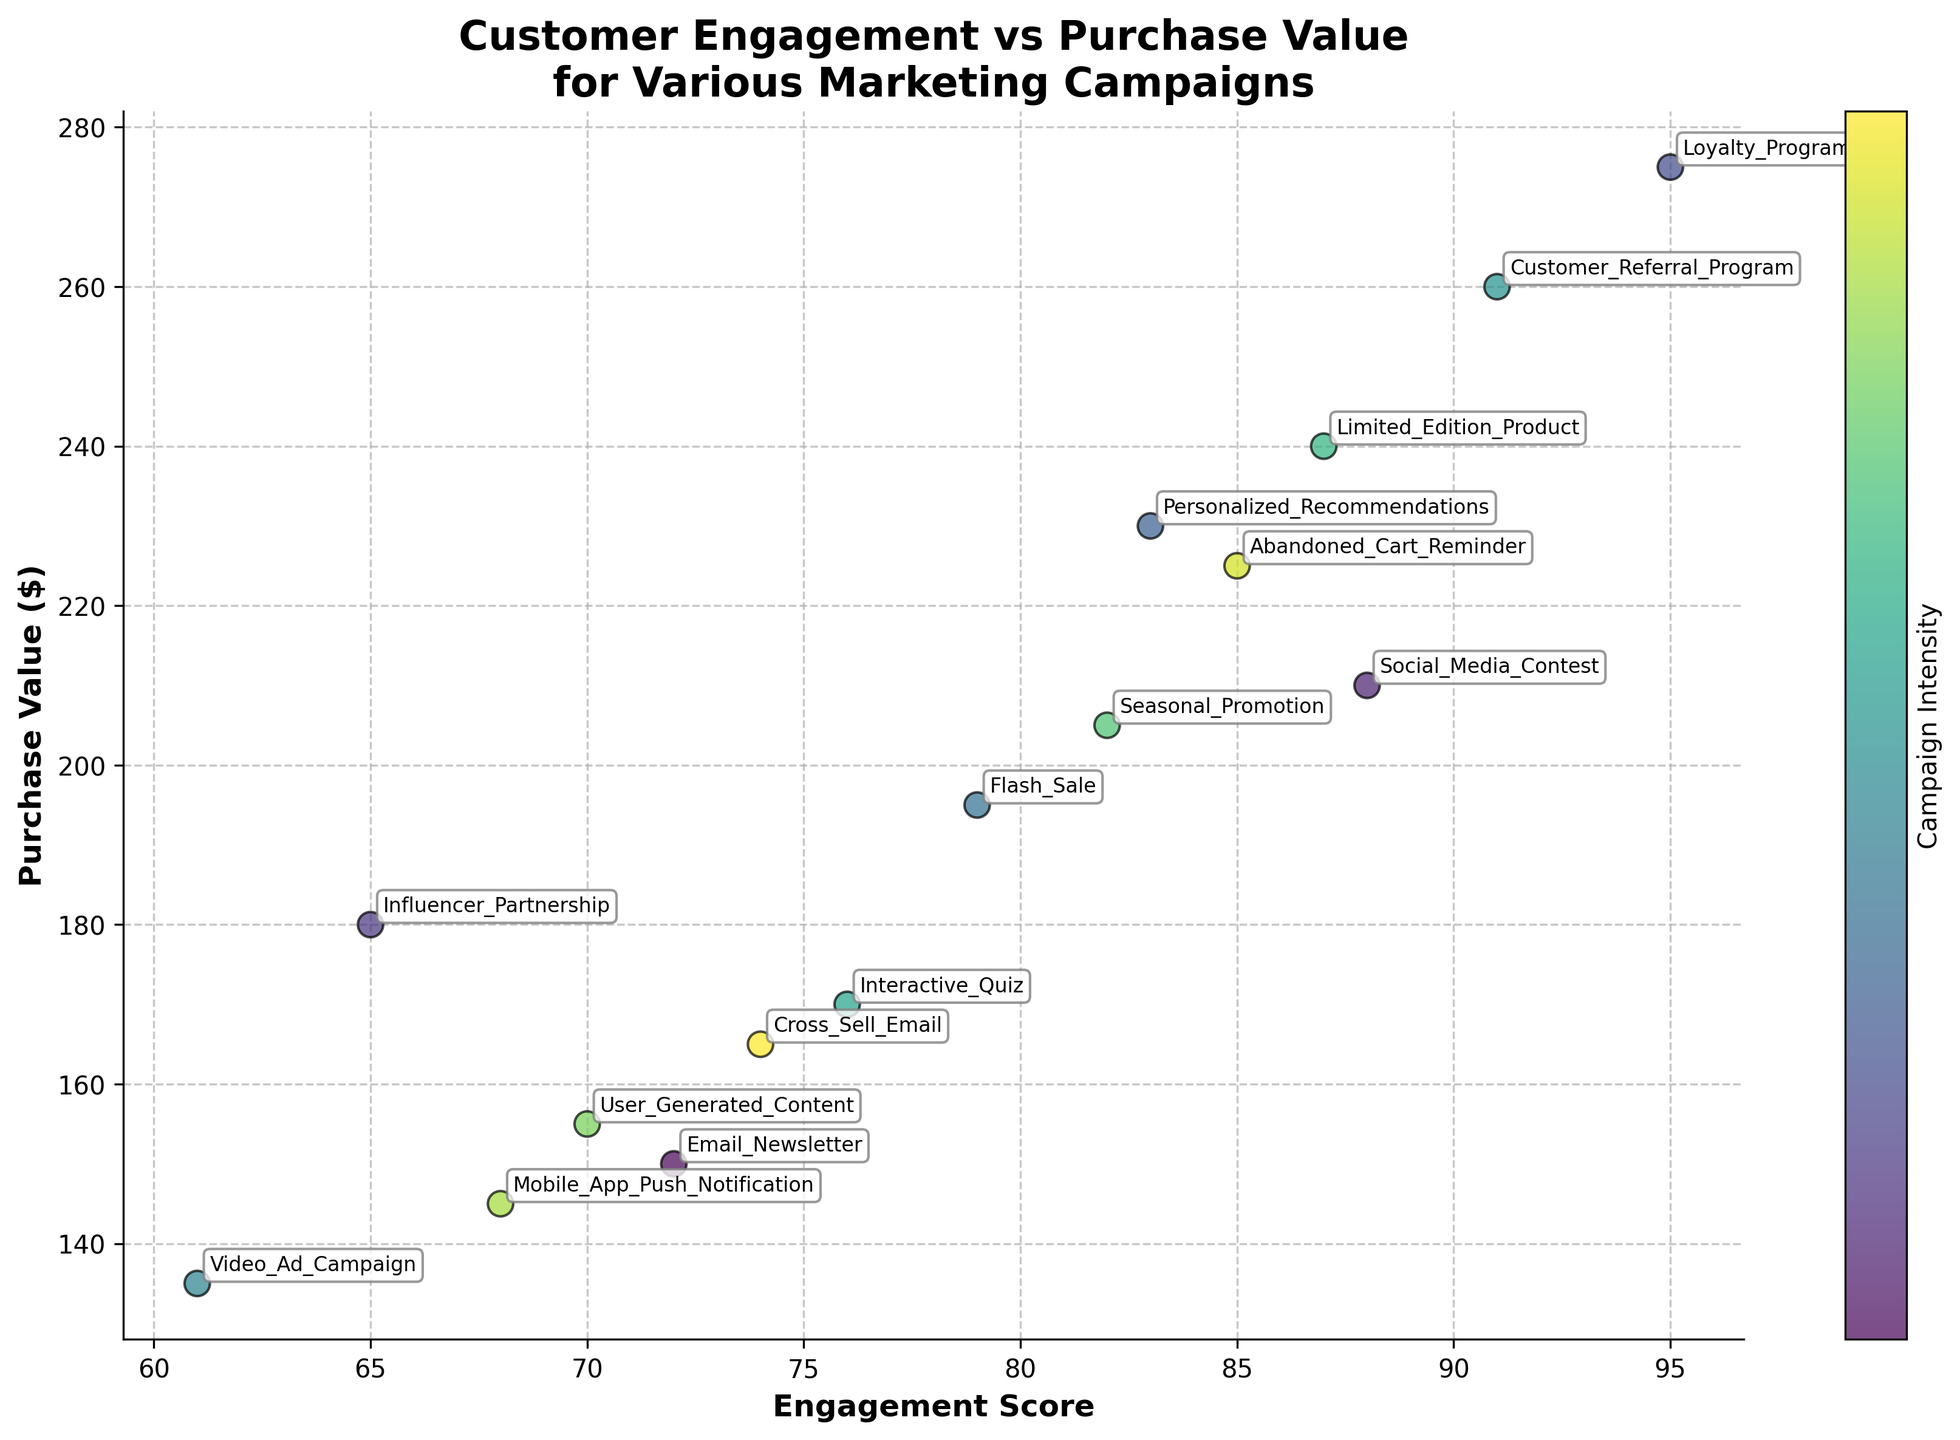What is the title of the plot? The title is displayed at the top of the plot and describes the overall data being shown. The title is detailed and should precisely describe the main focus of the plot.
Answer: Customer Engagement vs Purchase Value for Various Marketing Campaigns What are the x-axis and y-axis labels? The x-axis and y-axis labels are indicated along the axes in bold text. The x-axis label represents the horizontal component, and the y-axis label represents the vertical component.
Answer: Engagement Score; Purchase Value ($) How many campaigns are plotted in the figure? Each campaign is represented by a distinct data point in the scatter plot. The number of distinct annotations in the plot corresponds to the number of campaigns.
Answer: 15 Which campaign has the highest purchase value? Looking at the data points, the one with the highest y-value represents the campaign with the highest purchase value. The data point will likely have an annotation.
Answer: Loyalty Program Which campaigns have engagement scores above 80? Identify the data points to the right of the 80 mark on the x-axis. The annotations at or near these points represent the relevant campaigns.
Answer: Loyalty Program, Personalized Recommendations, Social Media Contest, Limited Edition Product, Customer Referral Program, Abandoned Cart Reminder, Seasonal Promotion Which campaign shows the lowest engagement score? Look for the data point with the lowest x-value. The annotation near this data point indicates the campaign with the lowest engagement score.
Answer: Video Ad Campaign Are there any campaigns that cluster together closely, and what are they? Clusters are identified by observing data points (and their annotations) that are spatially close to each other in the plot.
Answer: Flash Sale & Cross Sell Email What is the engagement score and purchase value for the 'Interactive Quiz' campaign? Locate the 'Interactive Quiz' annotation on the plot and read the x (engagement score) and y (purchase value) coordinates corresponding to this point.
Answer: 76; 170 